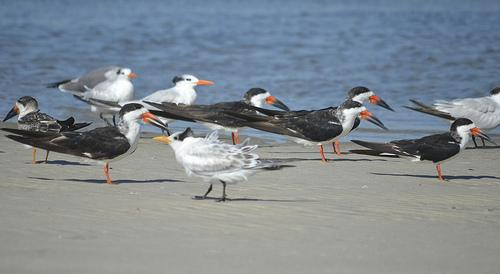What color are the birds' legs, and how would you describe their beaks? The birds have orange legs and orange and black beaks. Give a brief summary of the overall scene depicted in the image. The image shows a group of birds with various features standing on a smooth sandy beach near the blue, choppy ocean water during daytime. How many birds are shown in the image, and what are they doing? There are eleven birds in total, standing on the shore and facing different directions. What is the primary difference between the adult and baby shorebirds in the picture? Adult shorebirds have dark wings and caps, while the baby bird has black legs and ruffled feathers. In your own words, describe the appearance of the bird with the dark legs. The bird has dark legs, white feathers with grey highlights, and dark feathers on the head, making it look like a helmet. Could you provide the description of the bird with the yellow beak? The bird is white, with a yellow beak and black eye, and has white feathers on its neck and part of its head. Describe the bird with the long orange and black beak. The bird has a long, distinct orange and black beak, black feathers on its body with white highlights, and orange legs. What is the dominant color of the water in this image? The dominant color of the water in the image is blue. How would you characterize the state of the ocean in the image? The ocean has a rough chop, with blue, choppy water in the background. What is the texture of the sand on the beach, and how does it contrast with the water? The sand on the beach is smooth, providing a contrasting texture with the rough, choppy ocean water. Can you spot any birds with green wings facing left in the image? No, it's not mentioned in the image. Do you see any bird with a blue beak and black feathers on its head like a helmet?  Although a bird with black feathers on its head like a helmet is mentioned, there is no mention of a bird with a blue beak. The attribute of the blue beak is incorrect. Can you find the purple ocean behind the birds in the photo? The ocean is described as blue, not purple. The mentioned color attribute is incorrect. 